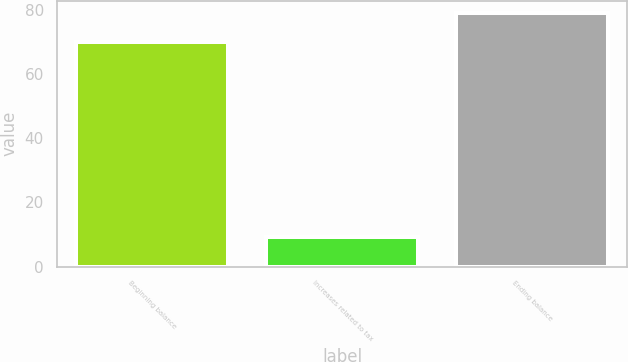Convert chart. <chart><loc_0><loc_0><loc_500><loc_500><bar_chart><fcel>Beginning balance<fcel>Increases related to tax<fcel>Ending balance<nl><fcel>70<fcel>9.1<fcel>78.9<nl></chart> 